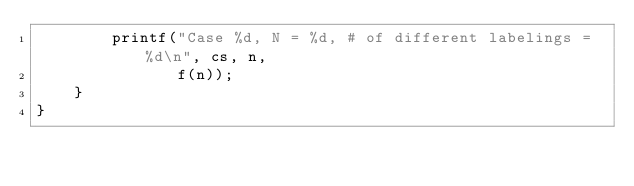<code> <loc_0><loc_0><loc_500><loc_500><_C++_>        printf("Case %d, N = %d, # of different labelings = %d\n", cs, n,
               f(n));
    }
}
</code> 